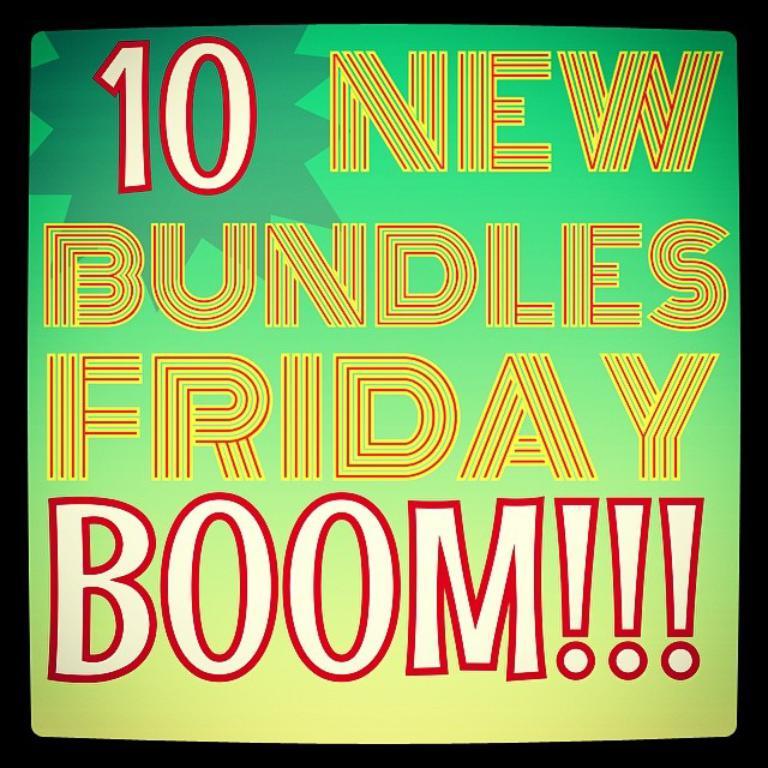What number is shown?
Provide a succinct answer. 10. How many new bundles?
Provide a short and direct response. 10. 